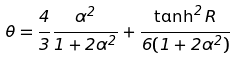<formula> <loc_0><loc_0><loc_500><loc_500>\theta = \frac { 4 } { 3 } \frac { \alpha ^ { 2 } } { 1 + 2 \alpha ^ { 2 } } + \frac { \tanh ^ { 2 } R } { 6 ( 1 + 2 \alpha ^ { 2 } ) }</formula> 